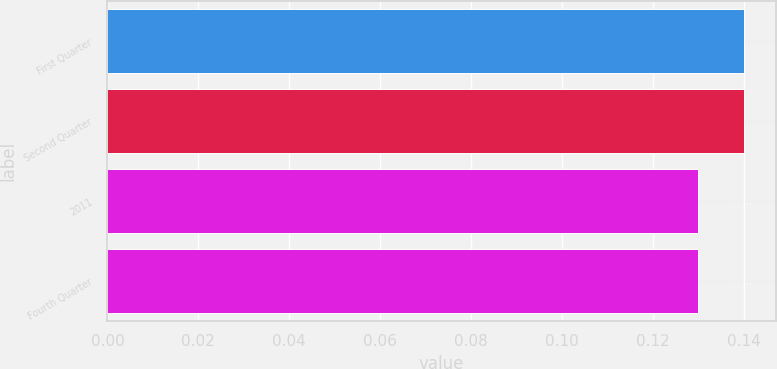<chart> <loc_0><loc_0><loc_500><loc_500><bar_chart><fcel>First Quarter<fcel>Second Quarter<fcel>2011<fcel>Fourth Quarter<nl><fcel>0.14<fcel>0.14<fcel>0.13<fcel>0.13<nl></chart> 